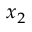<formula> <loc_0><loc_0><loc_500><loc_500>x _ { 2 }</formula> 